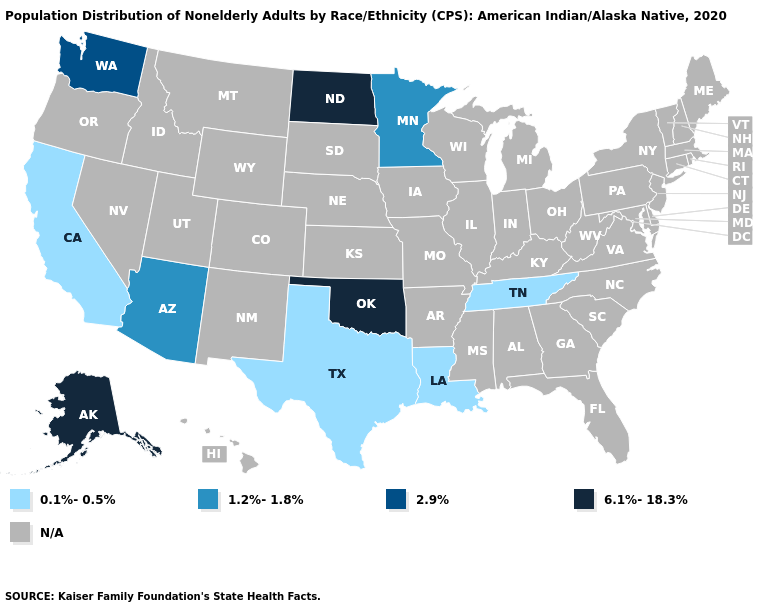What is the value of West Virginia?
Quick response, please. N/A. Is the legend a continuous bar?
Give a very brief answer. No. What is the value of South Dakota?
Be succinct. N/A. What is the value of Virginia?
Be succinct. N/A. Name the states that have a value in the range 2.9%?
Be succinct. Washington. What is the value of North Dakota?
Keep it brief. 6.1%-18.3%. Name the states that have a value in the range 2.9%?
Keep it brief. Washington. Name the states that have a value in the range 1.2%-1.8%?
Give a very brief answer. Arizona, Minnesota. Does Minnesota have the lowest value in the USA?
Answer briefly. No. What is the lowest value in the USA?
Answer briefly. 0.1%-0.5%. Name the states that have a value in the range 1.2%-1.8%?
Short answer required. Arizona, Minnesota. 